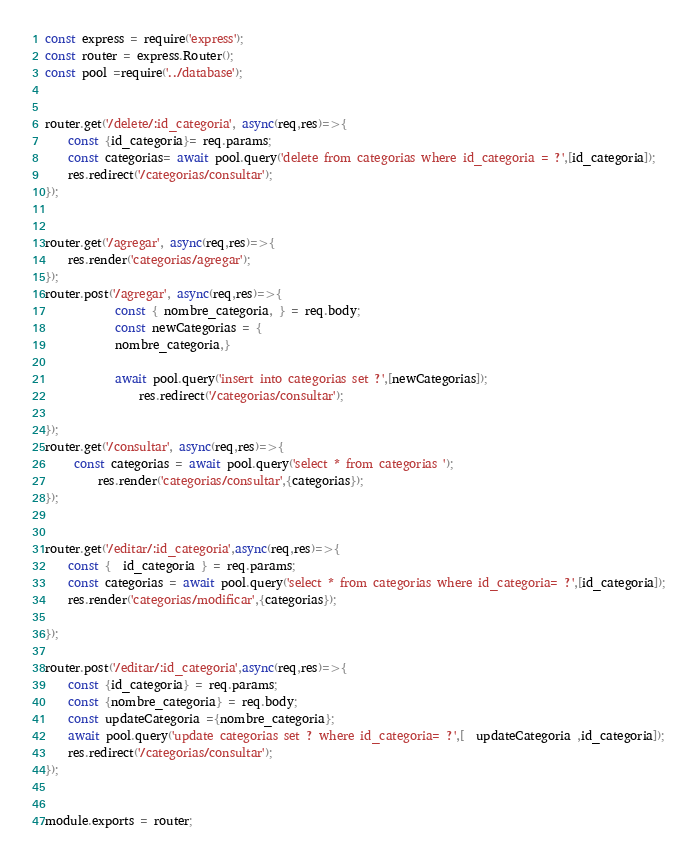Convert code to text. <code><loc_0><loc_0><loc_500><loc_500><_JavaScript_>const express = require('express');
const router = express.Router();
const pool =require('../database');


router.get('/delete/:id_categoria', async(req,res)=>{
    const {id_categoria}= req.params;
    const categorias= await pool.query('delete from categorias where id_categoria = ?',[id_categoria]);
    res.redirect('/categorias/consultar');
}); 


router.get('/agregar', async(req,res)=>{
    res.render('categorias/agregar');
}); 
router.post('/agregar', async(req,res)=>{
            const { nombre_categoria, } = req.body;
            const newCategorias = {
            nombre_categoria,}
            
            await pool.query('insert into categorias set ?',[newCategorias]);
                res.redirect('/categorias/consultar');

}); 
router.get('/consultar', async(req,res)=>{
     const categorias = await pool.query('select * from categorias ');
         res.render('categorias/consultar',{categorias});
});    


router.get('/editar/:id_categoria',async(req,res)=>{
    const {  id_categoria } = req.params;
    const categorias = await pool.query('select * from categorias where id_categoria= ?',[id_categoria]);
    res.render('categorias/modificar',{categorias});

});

router.post('/editar/:id_categoria',async(req,res)=>{
    const {id_categoria} = req.params;
    const {nombre_categoria} = req.body;
    const updateCategoria ={nombre_categoria};
    await pool.query('update categorias set ? where id_categoria= ?',[  updateCategoria ,id_categoria]);
    res.redirect('/categorias/consultar');
});


module.exports = router;</code> 